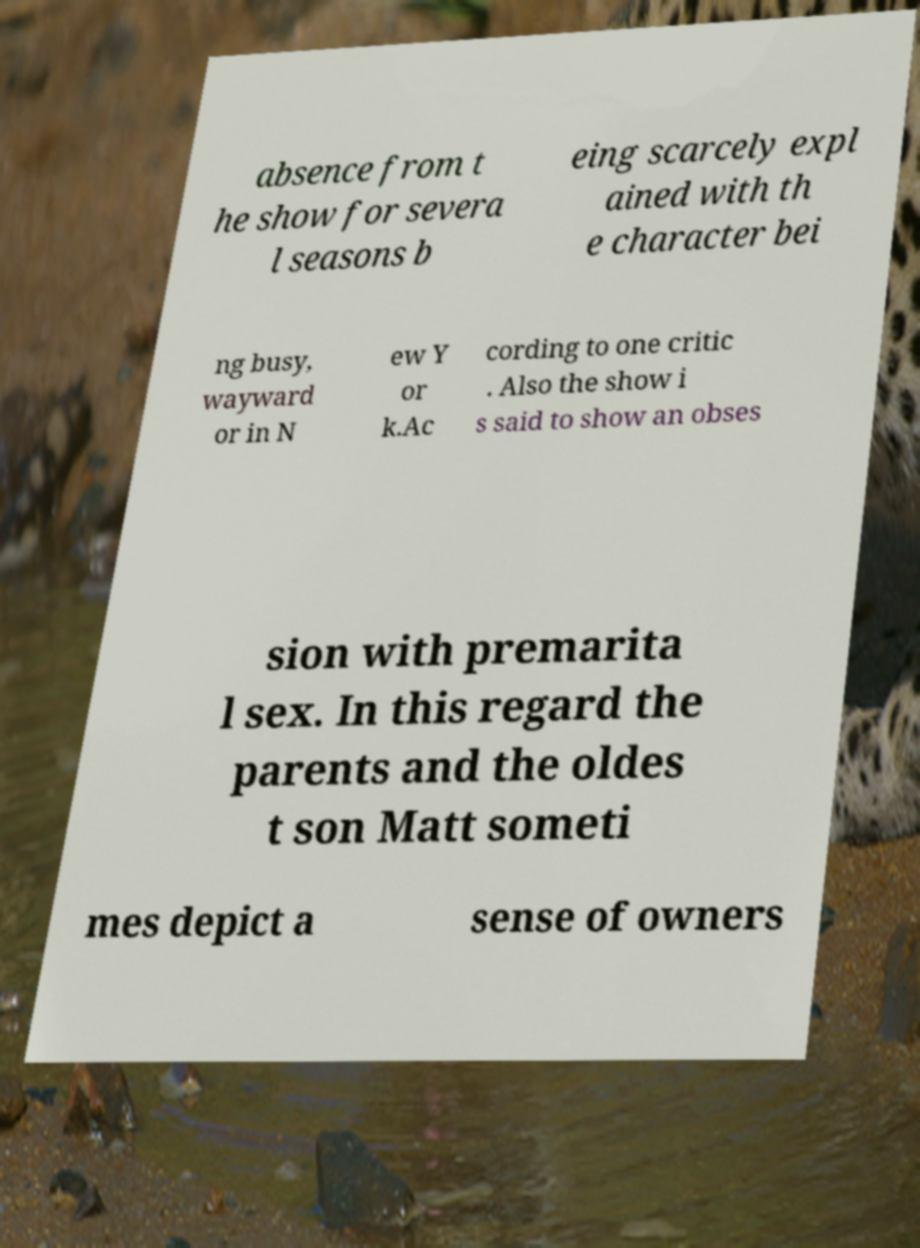Please identify and transcribe the text found in this image. absence from t he show for severa l seasons b eing scarcely expl ained with th e character bei ng busy, wayward or in N ew Y or k.Ac cording to one critic . Also the show i s said to show an obses sion with premarita l sex. In this regard the parents and the oldes t son Matt someti mes depict a sense of owners 